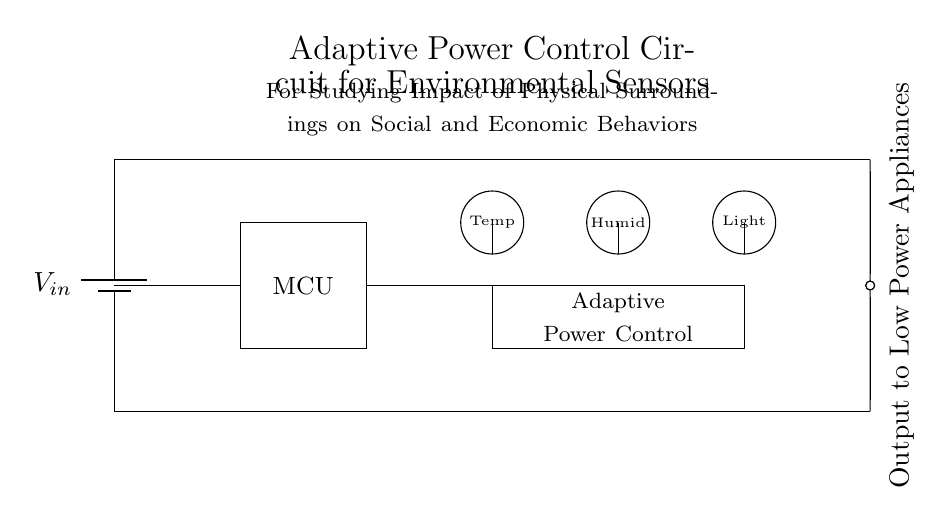What is the purpose of the adaptive power control in this circuit? The adaptive power control optimizes the energy usage of the circuit by regulating power to the sensors based on their environmental input, thus enabling efficient operation of low power appliances.
Answer: optimize energy usage How many environmental sensors are present in the circuit? There are three environmental sensors depicted in the diagram: a temperature sensor, a humidity sensor, and a light sensor.
Answer: three What does the acronym MCU stand for in this circuit? MCU stands for Microcontroller Unit, which is the brain of the circuit that processes data from the sensors and controls the adaptive power functionality.
Answer: Microcontroller Unit What component regulates power to the low power appliances? The adaptive power control component is responsible for regulating power to the low power appliances based on the readings from the environmental sensors.
Answer: adaptive power control Which physical factors are being monitored by the sensors in this circuit? The circuit monitors temperature, humidity, and light levels, which are essential physical factors that can impact social and economic behaviors.
Answer: temperature, humidity, light How is the output from this circuit directed to the appliances? The output is directed to low power appliances through a terminal that acts as an output node, indicated in the diagram.
Answer: output terminal 